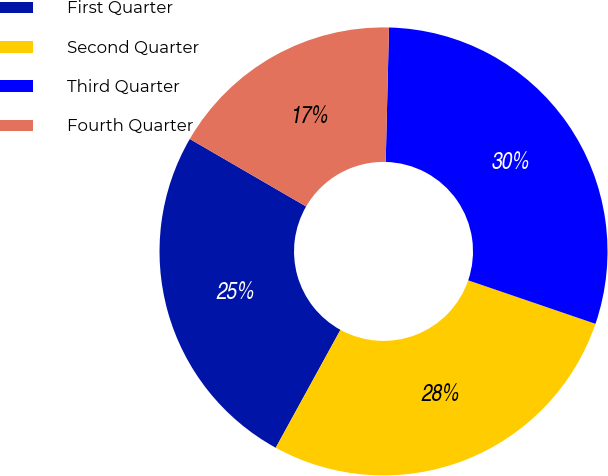Convert chart. <chart><loc_0><loc_0><loc_500><loc_500><pie_chart><fcel>First Quarter<fcel>Second Quarter<fcel>Third Quarter<fcel>Fourth Quarter<nl><fcel>25.38%<fcel>27.75%<fcel>29.85%<fcel>17.02%<nl></chart> 